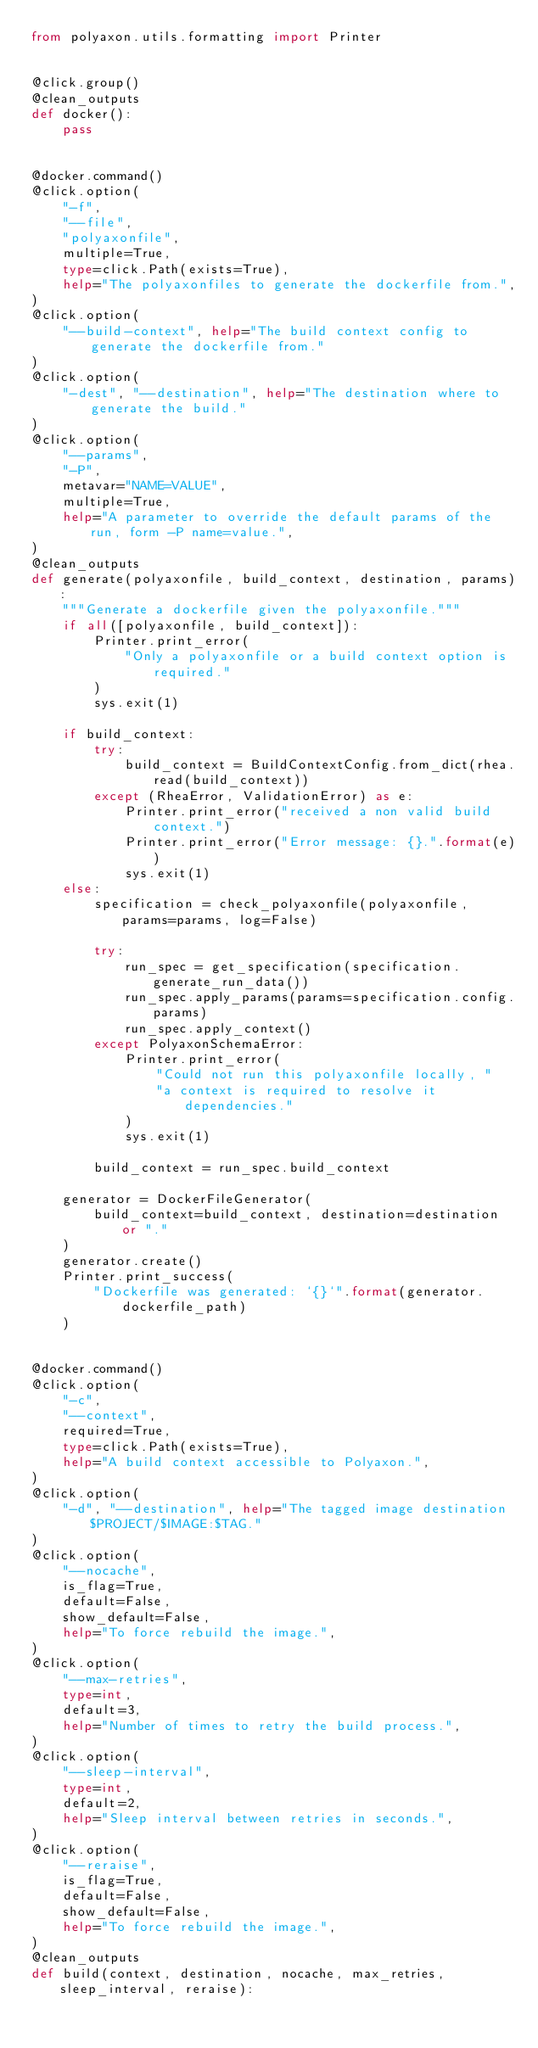Convert code to text. <code><loc_0><loc_0><loc_500><loc_500><_Python_>from polyaxon.utils.formatting import Printer


@click.group()
@clean_outputs
def docker():
    pass


@docker.command()
@click.option(
    "-f",
    "--file",
    "polyaxonfile",
    multiple=True,
    type=click.Path(exists=True),
    help="The polyaxonfiles to generate the dockerfile from.",
)
@click.option(
    "--build-context", help="The build context config to generate the dockerfile from."
)
@click.option(
    "-dest", "--destination", help="The destination where to generate the build."
)
@click.option(
    "--params",
    "-P",
    metavar="NAME=VALUE",
    multiple=True,
    help="A parameter to override the default params of the run, form -P name=value.",
)
@clean_outputs
def generate(polyaxonfile, build_context, destination, params):
    """Generate a dockerfile given the polyaxonfile."""
    if all([polyaxonfile, build_context]):
        Printer.print_error(
            "Only a polyaxonfile or a build context option is required."
        )
        sys.exit(1)

    if build_context:
        try:
            build_context = BuildContextConfig.from_dict(rhea.read(build_context))
        except (RheaError, ValidationError) as e:
            Printer.print_error("received a non valid build context.")
            Printer.print_error("Error message: {}.".format(e))
            sys.exit(1)
    else:
        specification = check_polyaxonfile(polyaxonfile, params=params, log=False)

        try:
            run_spec = get_specification(specification.generate_run_data())
            run_spec.apply_params(params=specification.config.params)
            run_spec.apply_context()
        except PolyaxonSchemaError:
            Printer.print_error(
                "Could not run this polyaxonfile locally, "
                "a context is required to resolve it dependencies."
            )
            sys.exit(1)

        build_context = run_spec.build_context

    generator = DockerFileGenerator(
        build_context=build_context, destination=destination or "."
    )
    generator.create()
    Printer.print_success(
        "Dockerfile was generated: `{}`".format(generator.dockerfile_path)
    )


@docker.command()
@click.option(
    "-c",
    "--context",
    required=True,
    type=click.Path(exists=True),
    help="A build context accessible to Polyaxon.",
)
@click.option(
    "-d", "--destination", help="The tagged image destination $PROJECT/$IMAGE:$TAG."
)
@click.option(
    "--nocache",
    is_flag=True,
    default=False,
    show_default=False,
    help="To force rebuild the image.",
)
@click.option(
    "--max-retries",
    type=int,
    default=3,
    help="Number of times to retry the build process.",
)
@click.option(
    "--sleep-interval",
    type=int,
    default=2,
    help="Sleep interval between retries in seconds.",
)
@click.option(
    "--reraise",
    is_flag=True,
    default=False,
    show_default=False,
    help="To force rebuild the image.",
)
@clean_outputs
def build(context, destination, nocache, max_retries, sleep_interval, reraise):</code> 